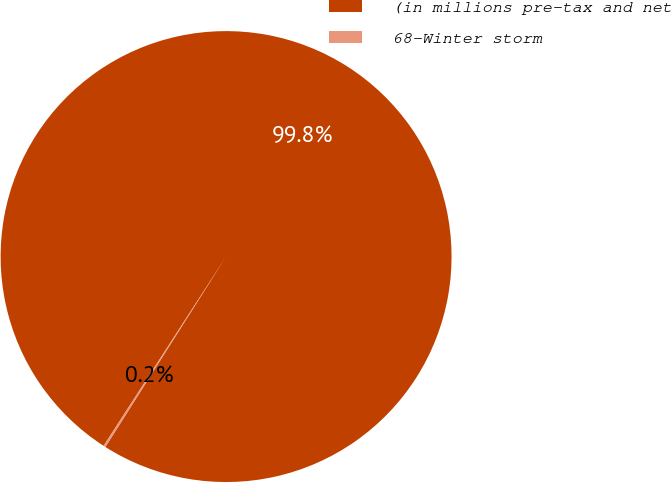Convert chart. <chart><loc_0><loc_0><loc_500><loc_500><pie_chart><fcel>(in millions pre-tax and net<fcel>68-Winter storm<nl><fcel>99.85%<fcel>0.15%<nl></chart> 